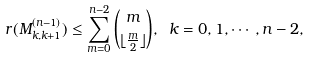<formula> <loc_0><loc_0><loc_500><loc_500>r ( M ^ { ( n - 1 ) } _ { k , k + 1 } ) \leq \sum _ { m = 0 } ^ { n - 2 } \binom { m } { \lfloor \frac { m } { 2 } \rfloor } , \ k = 0 , 1 , \cdots , n - 2 ,</formula> 